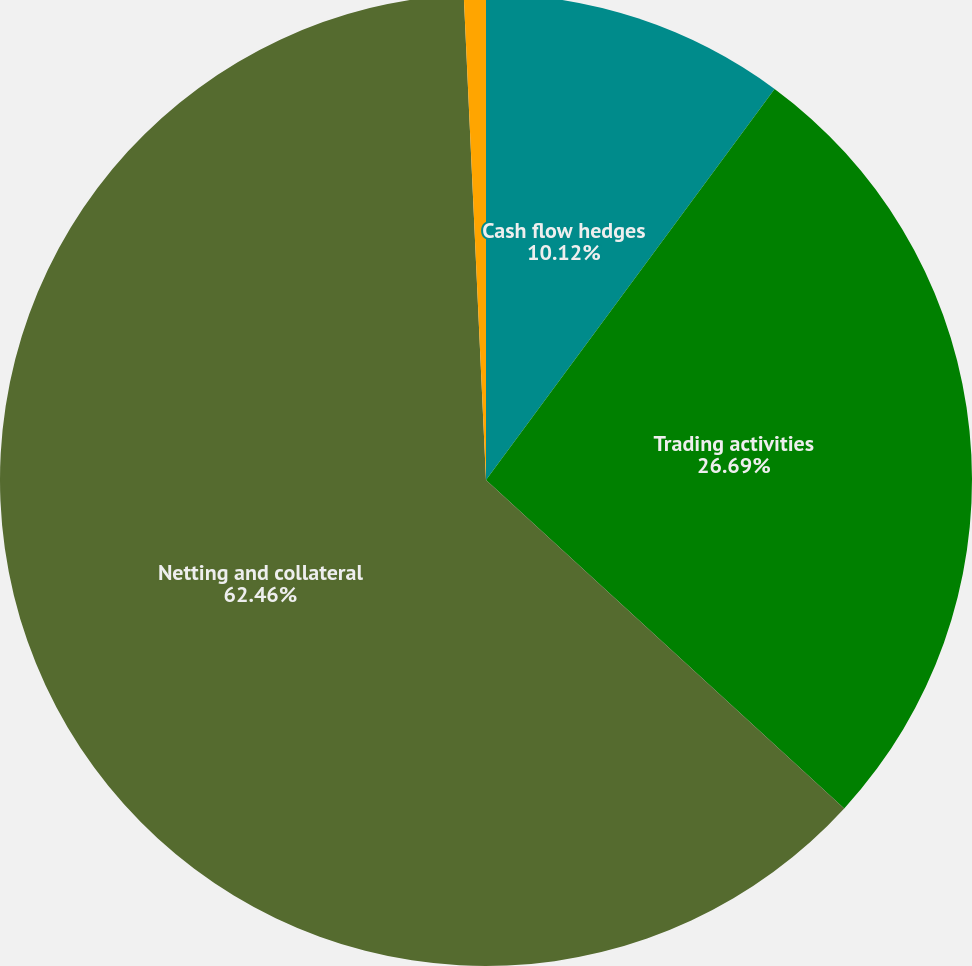Convert chart to OTSL. <chart><loc_0><loc_0><loc_500><loc_500><pie_chart><fcel>Cash flow hedges<fcel>Trading activities<fcel>Netting and collateral<fcel>Total<nl><fcel>10.12%<fcel>26.69%<fcel>62.46%<fcel>0.73%<nl></chart> 